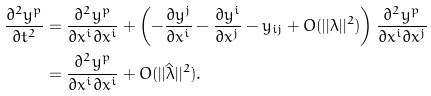<formula> <loc_0><loc_0><loc_500><loc_500>\frac { \partial ^ { 2 } y ^ { p } } { \partial t ^ { 2 } } & = \frac { \partial ^ { 2 } y ^ { p } } { \partial x ^ { i } \partial x ^ { i } } + \left ( - \frac { \partial y ^ { j } } { \partial x ^ { i } } - \frac { \partial y ^ { i } } { \partial x ^ { j } } - y _ { i j } + O ( | | \lambda | | ^ { 2 } ) \right ) \frac { \partial ^ { 2 } y ^ { p } } { \partial x ^ { i } \partial x ^ { j } } \\ & = \frac { \partial ^ { 2 } y ^ { p } } { \partial x ^ { i } \partial x ^ { i } } + O ( | | \hat { \lambda } | | ^ { 2 } ) .</formula> 